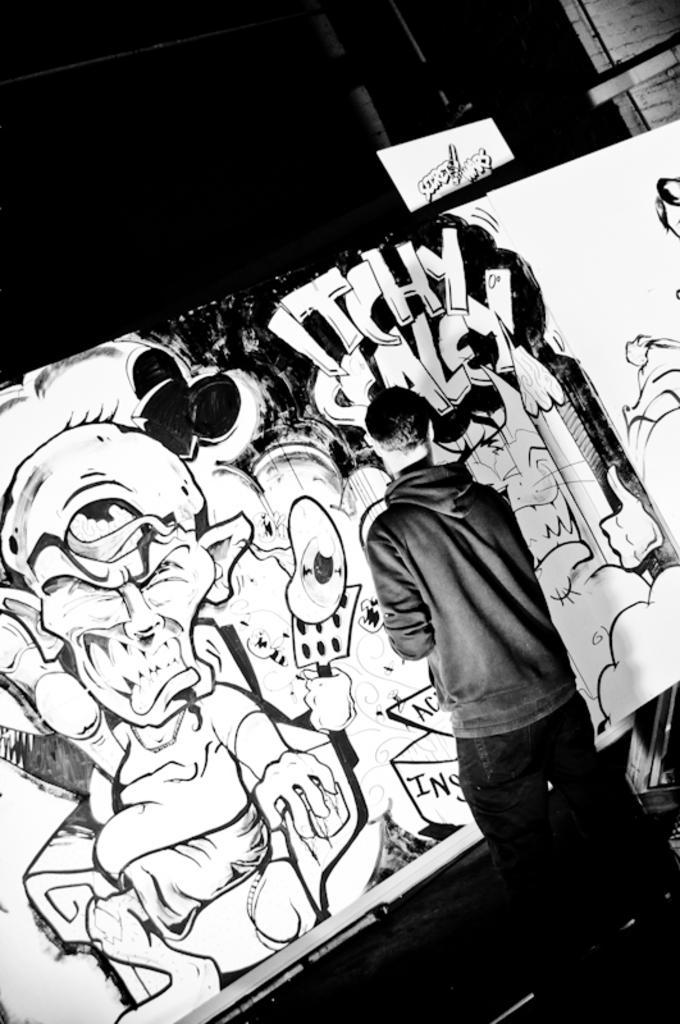How would you summarize this image in a sentence or two? In this image I can see a man is drawing an art on the board. This man wore sweater, trouser and it is in black and white image. 